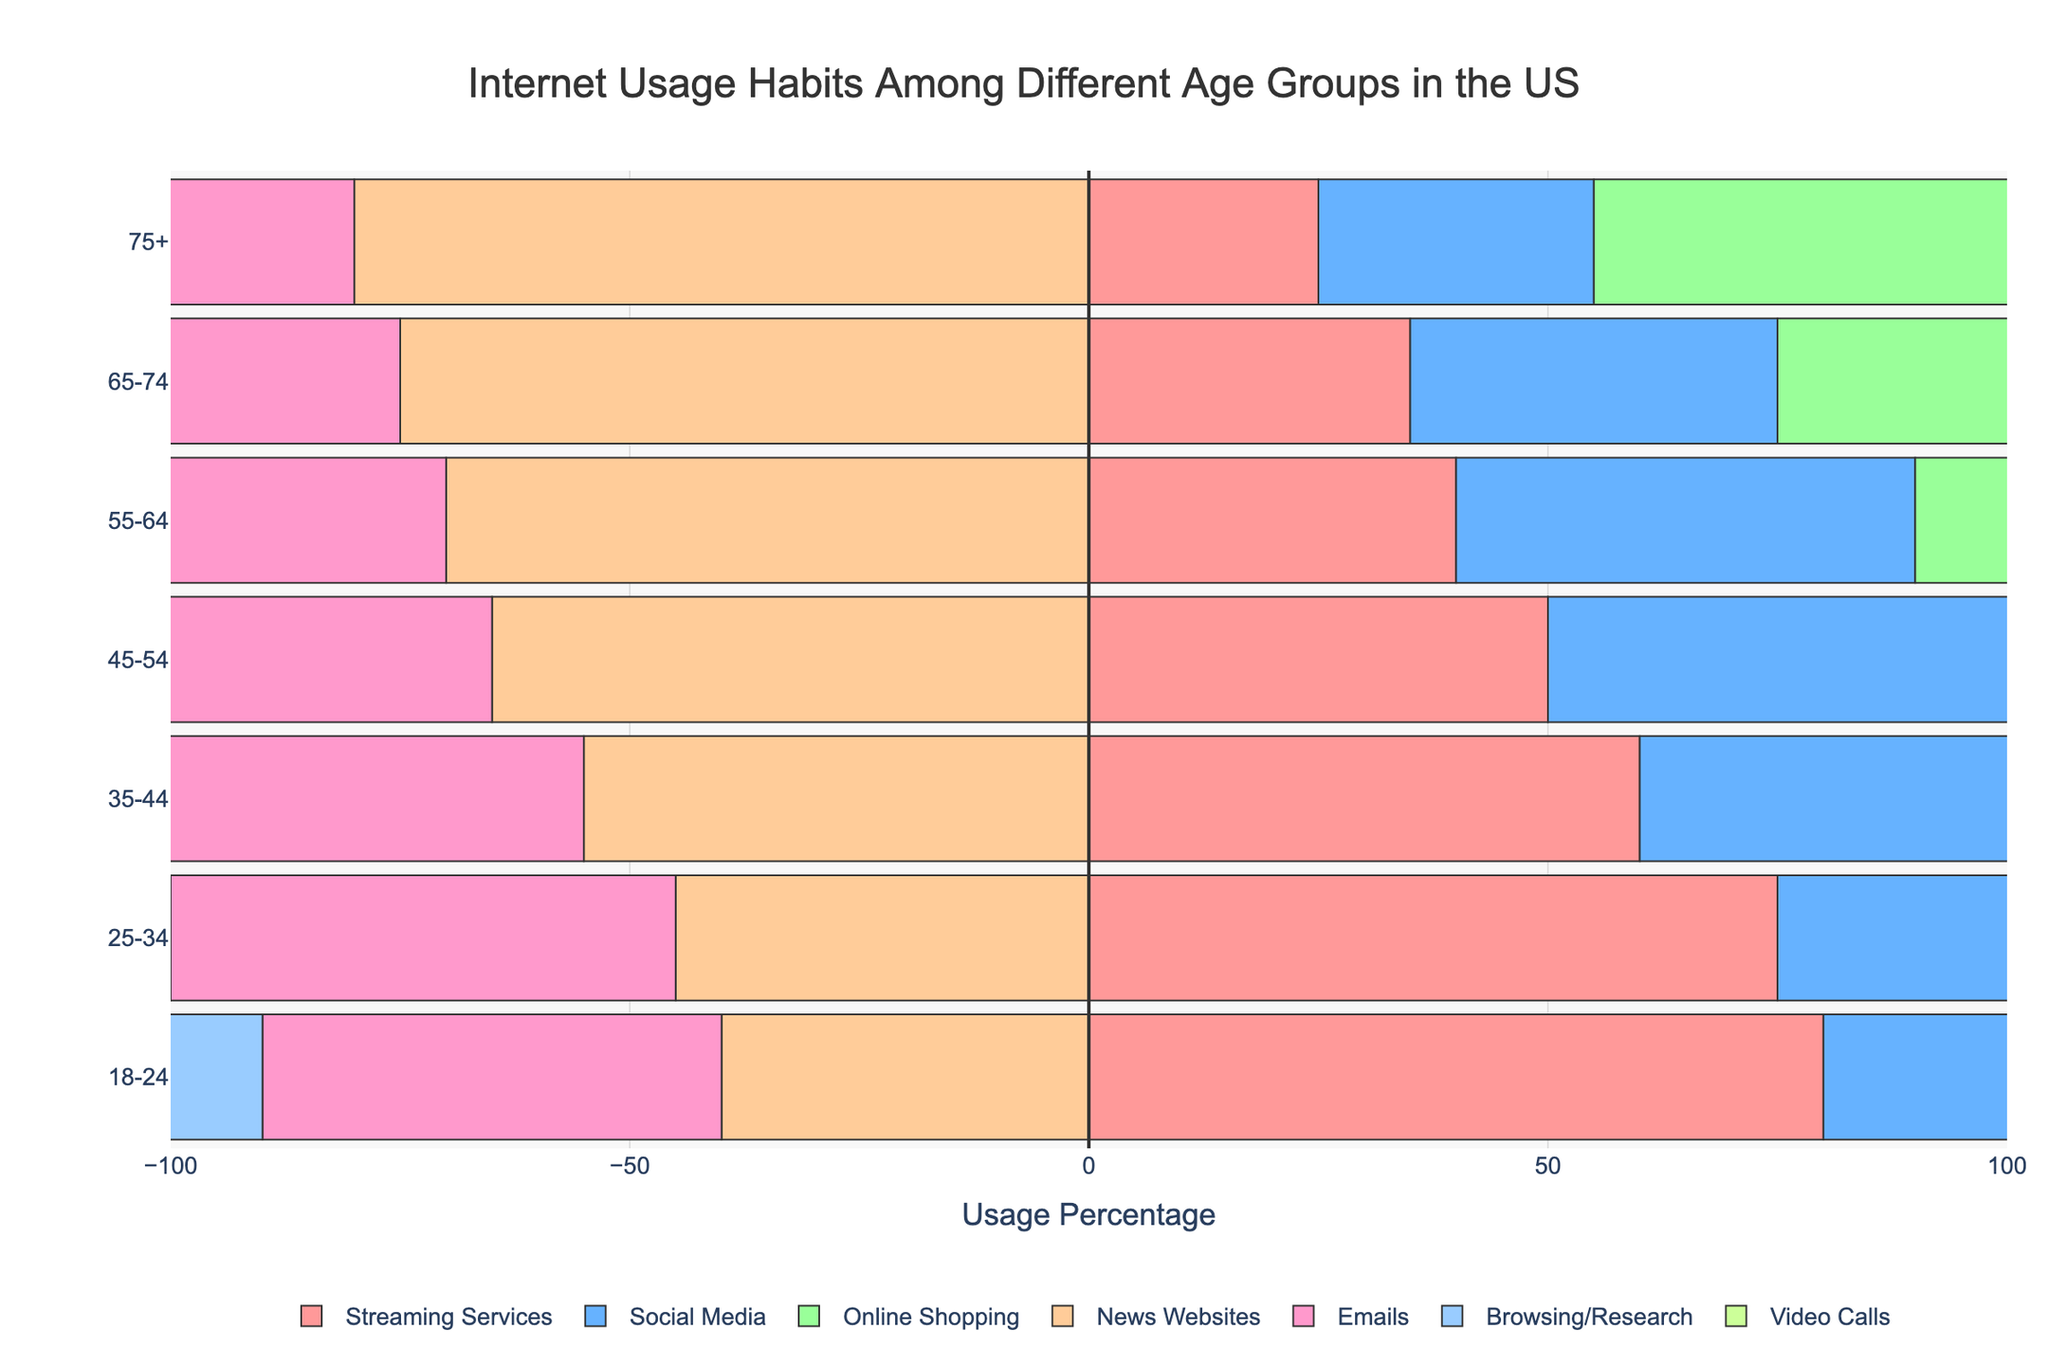How does the internet usage for video calls compare between the youngest and oldest age groups? The 18-24 age group shows 80% for video calls, whereas the 75+ age group shows 40%. The youngest uses video calls twice as much as the oldest.
Answer: 18-24 uses video calls twice as much as 75+ Which age group spends the most and the least time on browsing/research? The browsing/research category is the highest for the 18-24 age group at 90%, and the lowest for the 75+ age group at 45%. So, the 18-24 group spends the most, and the 75+ group spends the least time on browsing/research.
Answer: 18-24 is the highest, while 75+ is the lowest What is the difference in usage between online shopping and video calls within the 25-34 age group? For the 25-34 age group, the usage percentages are 80% for online shopping and 75% for video calls. The difference is 80% - 75% = 5%.
Answer: 5% Which age group has the highest usage for emails? The 75+ age group has the highest usage for emails at 85%.
Answer: 75+ has the highest What is the combined average usage percentage for streaming services, social media, and online shopping for the 35-44 age group? The usage percentages for the 35-44 age group are 60% for streaming services, 70% for social media, and 75% for online shopping. The combined average is (60 + 70 + 75) / 3 = 68.33%.
Answer: 68.33% Between the 25-34 and 55-64 age groups, which group shows a higher usage for social media and by how much? The 25-34 age group shows 65% for social media, and the 55-64 age group shows 50%. The difference is 65% - 50% = 15%.
Answer: 25-34 is higher by 15% How does the usage for news websites change from the 18-24 age group to the 65-74 age group? The usage for news websites increases from 40% in the 18-24 age group to 75% in the 65-74 age group, showing a 35% increase.
Answer: Increases by 35% What is the average usage percentage of video calls among all age groups? The usage percentages for video calls are 80%, 75%, 70%, 65%, 55%, 50%, and 40% for the respective age groups. The average is (80 + 75 + 70 + 65 + 55 + 50 + 40) / 7 ≈ 62.14%.
Answer: 62.14% Which two age groups have the closest usage percentages for streaming services and what are their percentages? The 55-64 age group has 40% and the 65-74 group has 35%, making them the closest in usage for streaming services.
Answer: 55-64 has 40% and 65-74 has 35% 